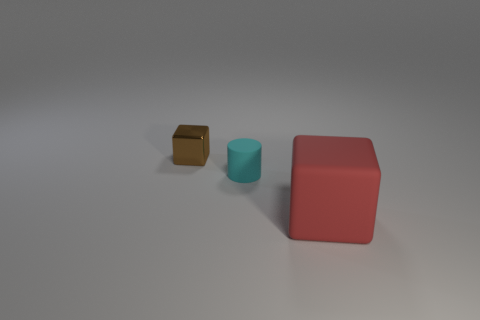The large matte thing that is the same shape as the brown shiny thing is what color?
Make the answer very short. Red. Is there any other thing that is the same shape as the big red rubber thing?
Offer a very short reply. Yes. How many cubes are either metal things or cyan things?
Offer a very short reply. 1. The tiny cyan object is what shape?
Offer a terse response. Cylinder. There is a small cyan rubber cylinder; are there any metallic blocks on the right side of it?
Ensure brevity in your answer.  No. Are the small brown cube and the small thing that is right of the brown metallic block made of the same material?
Offer a very short reply. No. Is the shape of the thing that is right of the tiny cyan rubber thing the same as  the cyan object?
Ensure brevity in your answer.  No. What number of other large blocks are the same material as the brown cube?
Make the answer very short. 0. What number of objects are either objects in front of the tiny cyan cylinder or gray metal cubes?
Keep it short and to the point. 1. How big is the brown shiny thing?
Ensure brevity in your answer.  Small. 